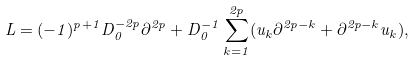Convert formula to latex. <formula><loc_0><loc_0><loc_500><loc_500>L = ( - 1 ) ^ { p + 1 } D _ { 0 } ^ { - 2 p } \partial ^ { 2 p } + D _ { 0 } ^ { - 1 } \sum _ { k = 1 } ^ { 2 p } ( u _ { k } \partial ^ { 2 p - k } + \partial ^ { 2 p - k } u _ { k } ) ,</formula> 